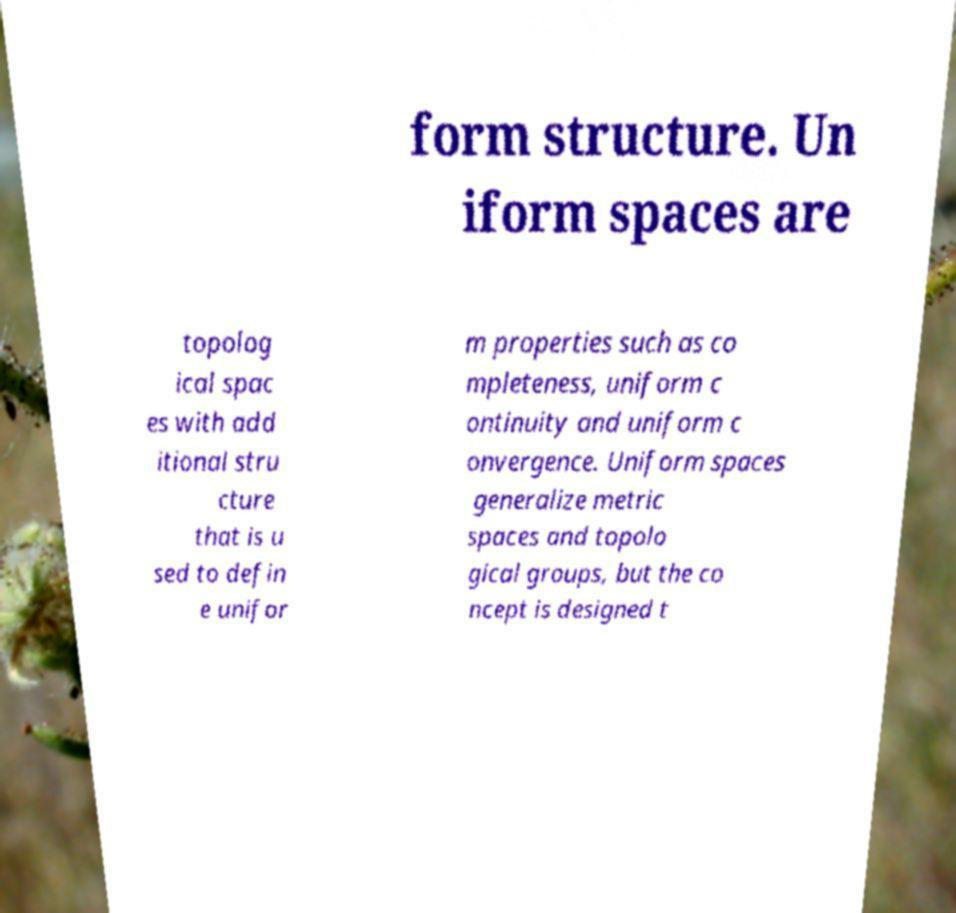Could you assist in decoding the text presented in this image and type it out clearly? form structure. Un iform spaces are topolog ical spac es with add itional stru cture that is u sed to defin e unifor m properties such as co mpleteness, uniform c ontinuity and uniform c onvergence. Uniform spaces generalize metric spaces and topolo gical groups, but the co ncept is designed t 